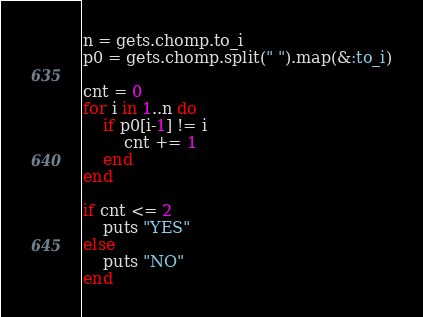Convert code to text. <code><loc_0><loc_0><loc_500><loc_500><_Ruby_>n = gets.chomp.to_i
p0 = gets.chomp.split(" ").map(&:to_i)

cnt = 0
for i in 1..n do
    if p0[i-1] != i
        cnt += 1
    end
end

if cnt <= 2
    puts "YES"
else
    puts "NO"
end</code> 